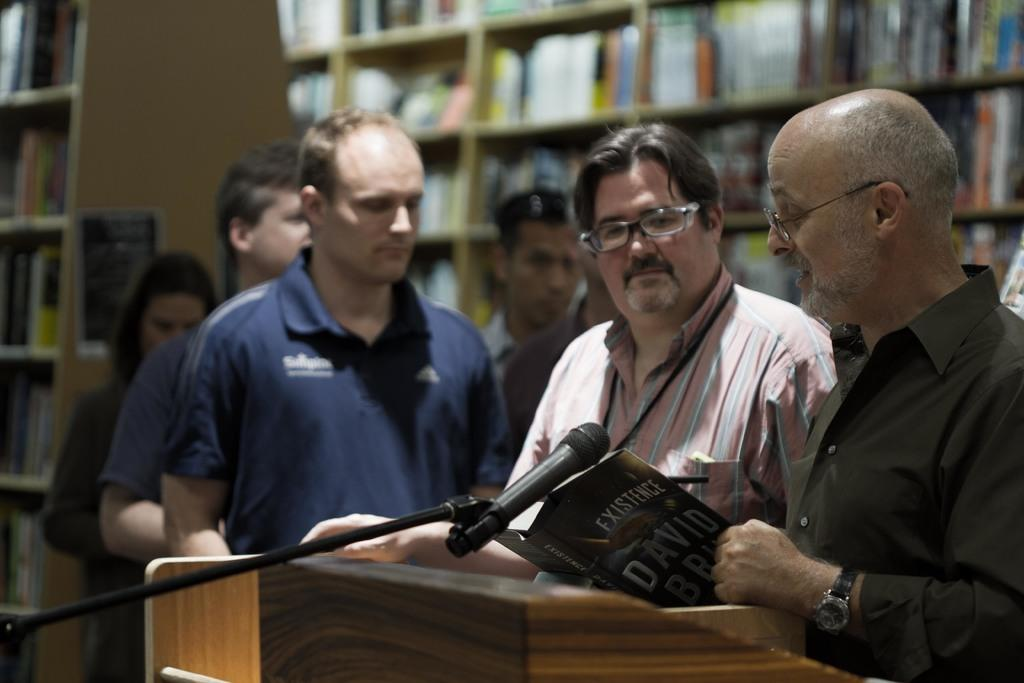Provide a one-sentence caption for the provided image. A group of men are reading a book called Existence at a podium. 